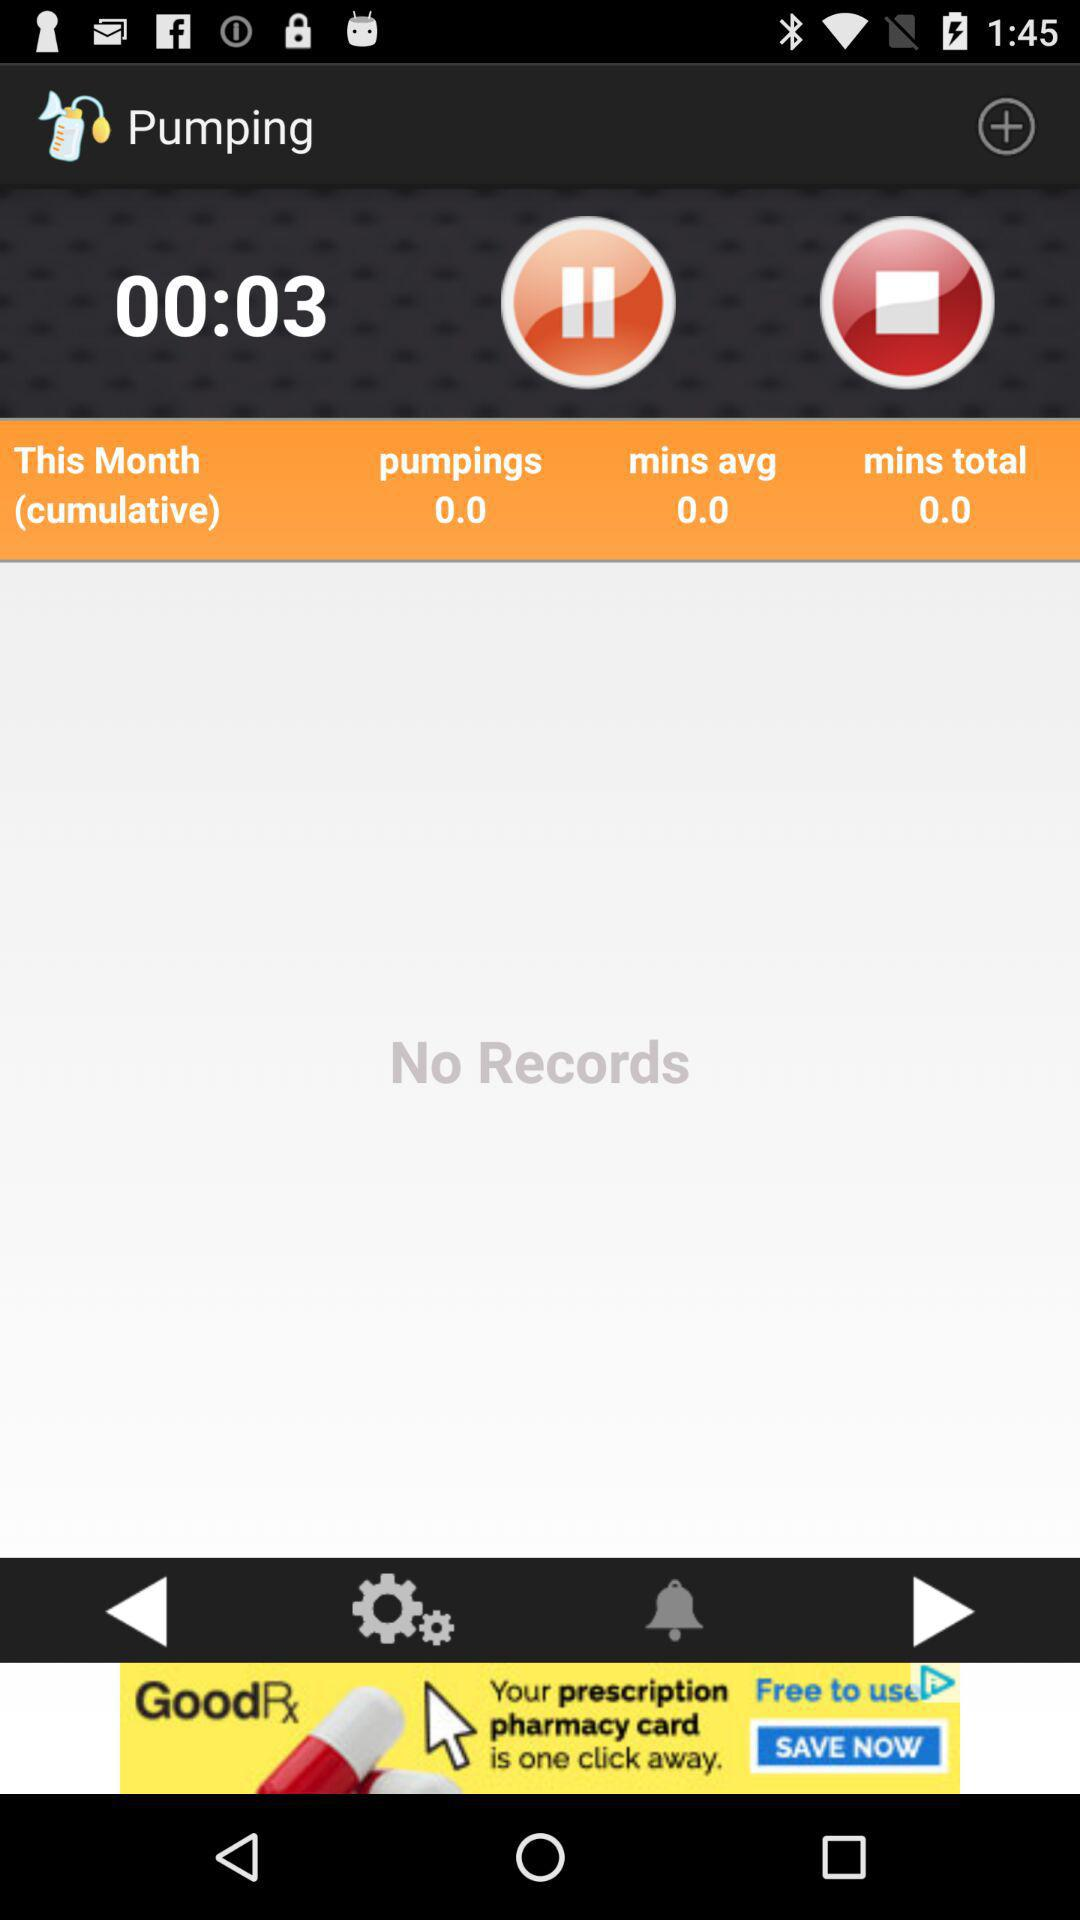How long has the pumping been going on for?
Answer the question using a single word or phrase. 00:03 